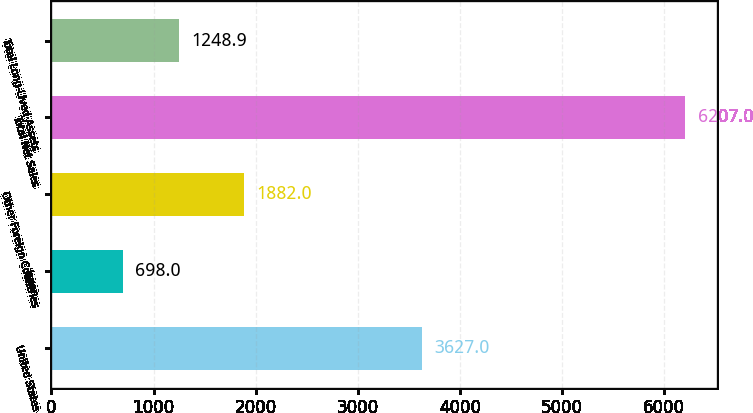Convert chart to OTSL. <chart><loc_0><loc_0><loc_500><loc_500><bar_chart><fcel>United States<fcel>Japan<fcel>Other Foreign Countries<fcel>Total Net Sales<fcel>Total Long-Lived Assets<nl><fcel>3627<fcel>698<fcel>1882<fcel>6207<fcel>1248.9<nl></chart> 